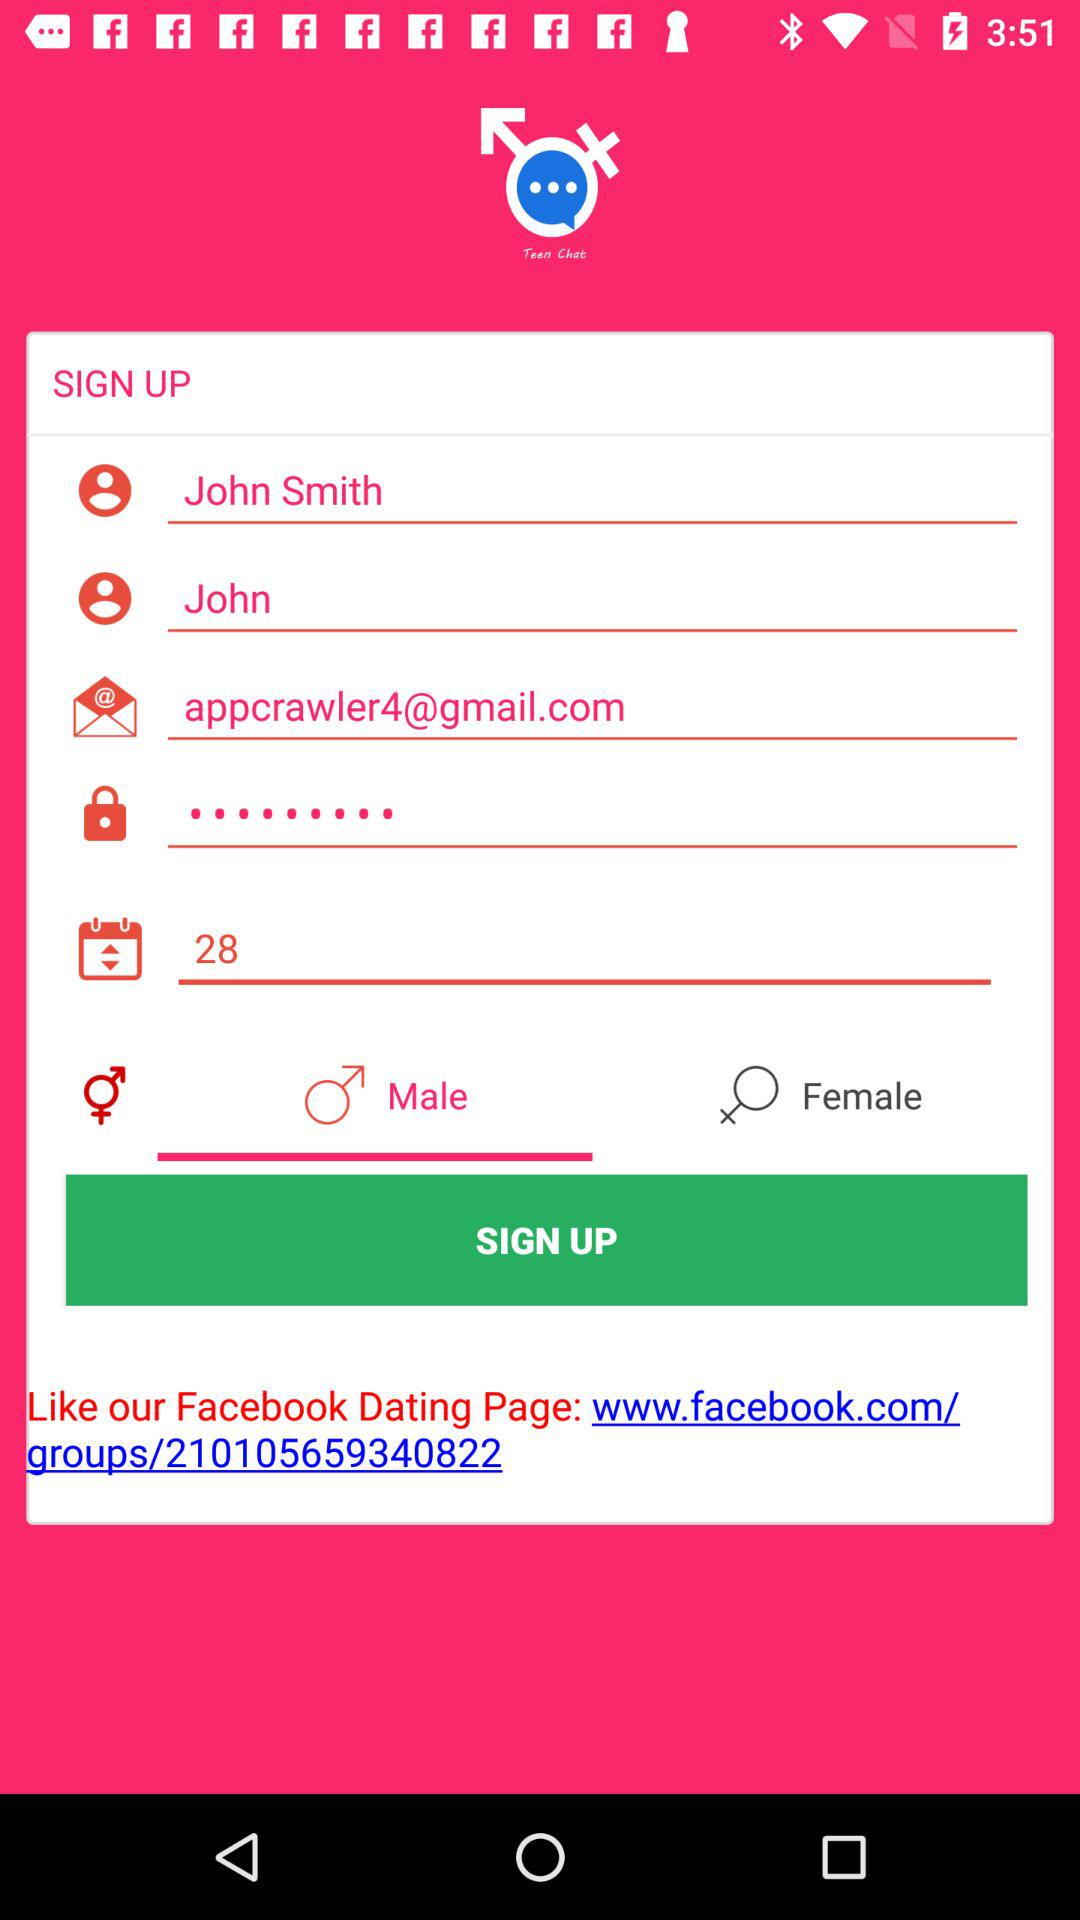What is the email address? The email address is appcrawler4@gmail.com. 